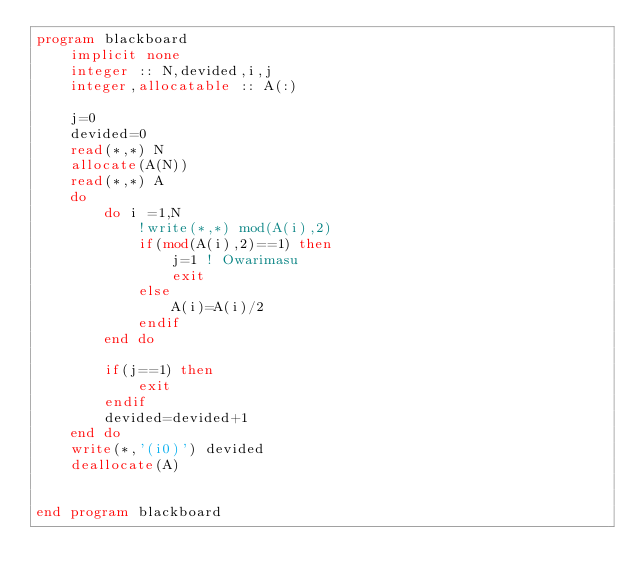Convert code to text. <code><loc_0><loc_0><loc_500><loc_500><_FORTRAN_>program blackboard
	implicit none
    integer :: N,devided,i,j
    integer,allocatable :: A(:)
    
    j=0
    devided=0
    read(*,*) N
    allocate(A(N))
    read(*,*) A
    do
    	do i =1,N
        	!write(*,*) mod(A(i),2)
            if(mod(A(i),2)==1) then           	
        		j=1 ! Owarimasu
                exit
            else
            	A(i)=A(i)/2
            endif
        end do
        
        if(j==1) then
        	exit
        endif
        devided=devided+1
    end do
    write(*,'(i0)') devided
    deallocate(A)
    
    
end program blackboard</code> 